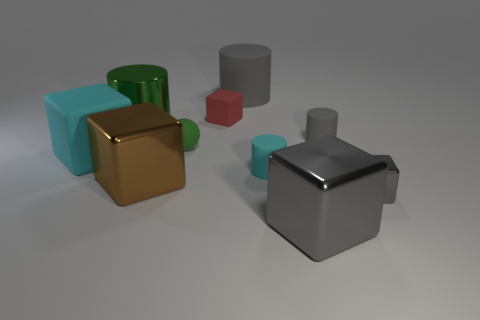Subtract 1 cylinders. How many cylinders are left? 3 Subtract all cyan cubes. How many cubes are left? 4 Subtract all small rubber blocks. How many blocks are left? 4 Subtract all purple blocks. Subtract all red cylinders. How many blocks are left? 5 Subtract all cylinders. How many objects are left? 6 Subtract all big blue shiny objects. Subtract all shiny cubes. How many objects are left? 7 Add 7 tiny gray shiny cubes. How many tiny gray shiny cubes are left? 8 Add 8 tiny brown matte cylinders. How many tiny brown matte cylinders exist? 8 Subtract 0 gray spheres. How many objects are left? 10 